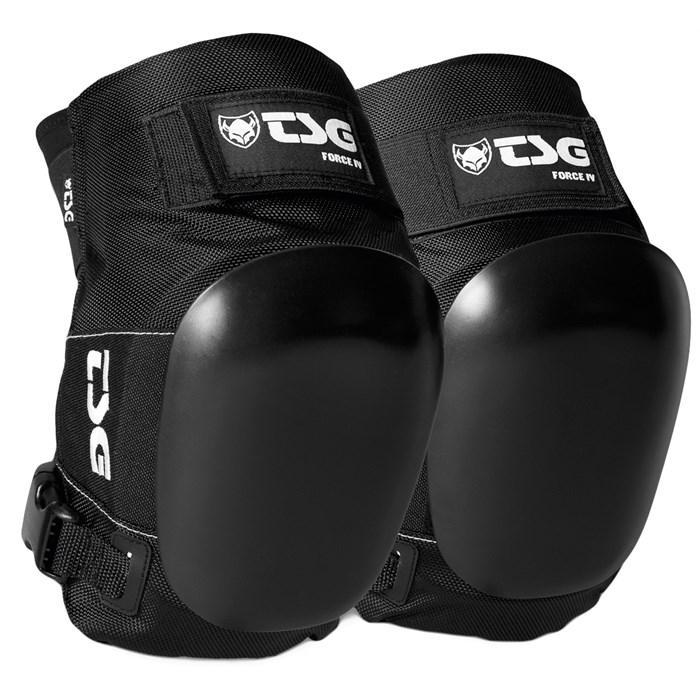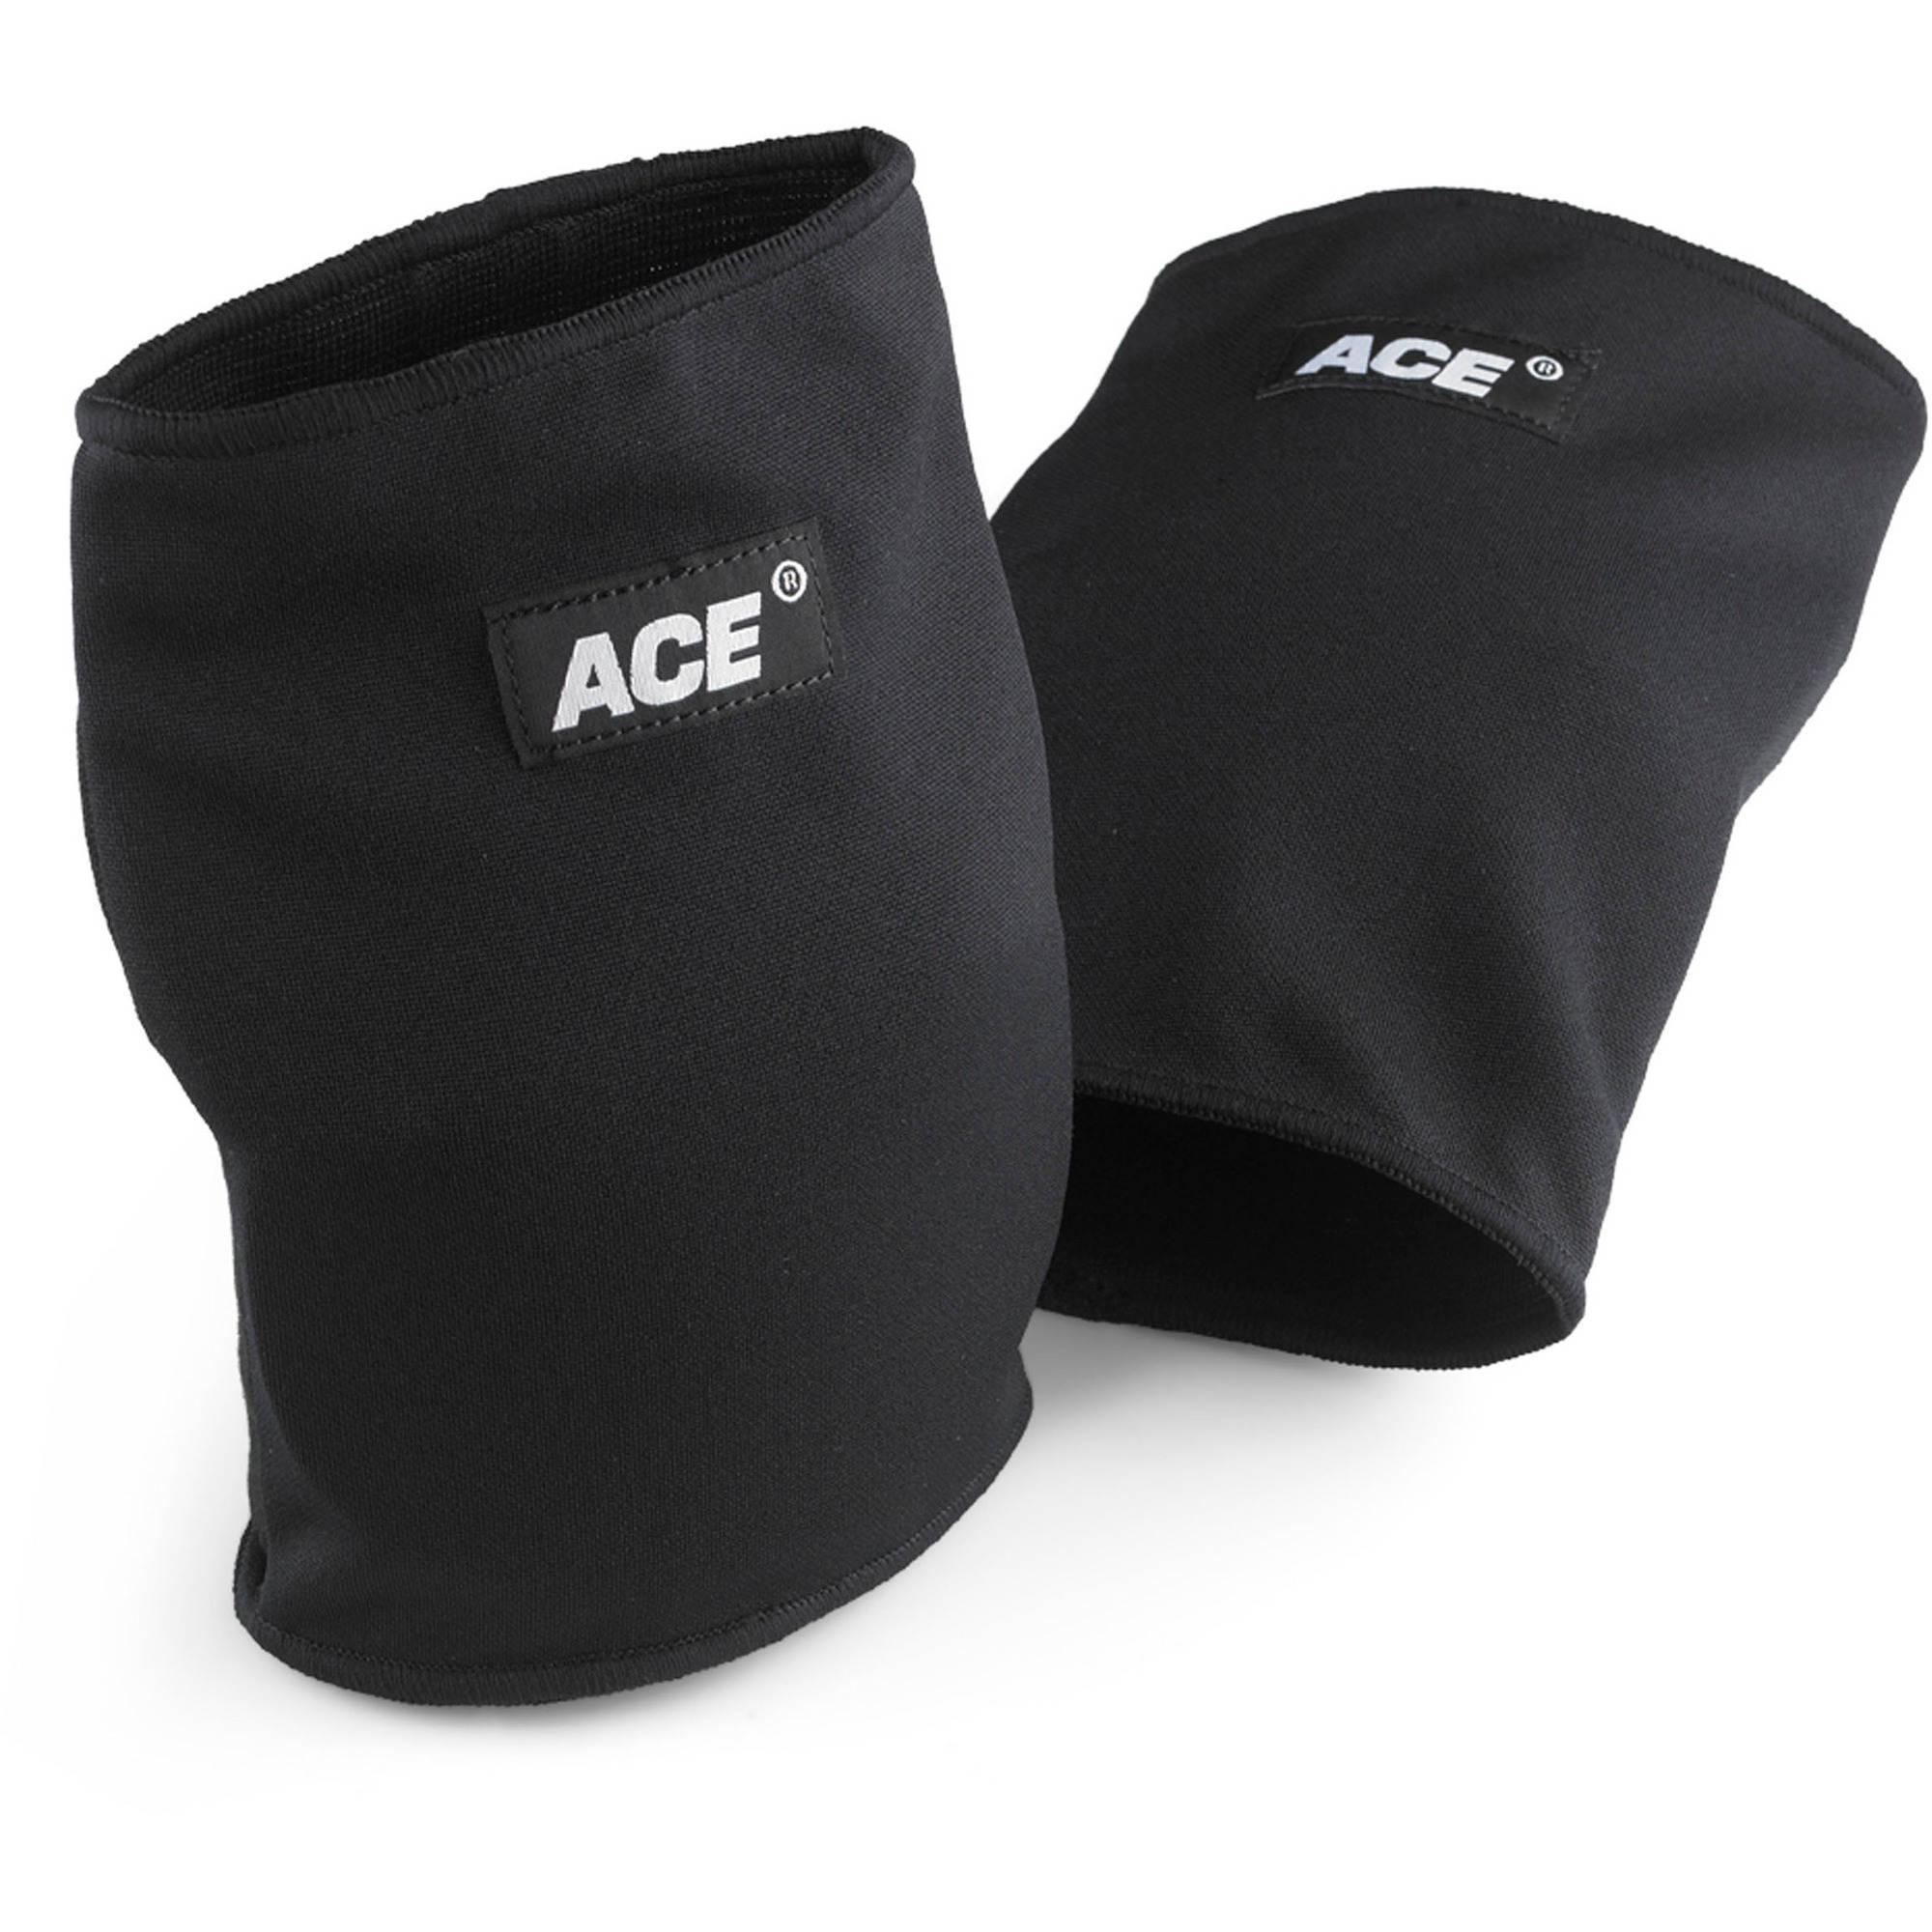The first image is the image on the left, the second image is the image on the right. Analyze the images presented: Is the assertion "Right image shows a pair of black kneepads turned rightward." valid? Answer yes or no. No. The first image is the image on the left, the second image is the image on the right. Assess this claim about the two images: "The pair of pads on the left is flat on the surface, facing the camera.". Correct or not? Answer yes or no. No. 